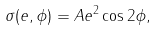Convert formula to latex. <formula><loc_0><loc_0><loc_500><loc_500>\sigma ( e , \phi ) = A e ^ { 2 } \cos { 2 \phi } ,</formula> 